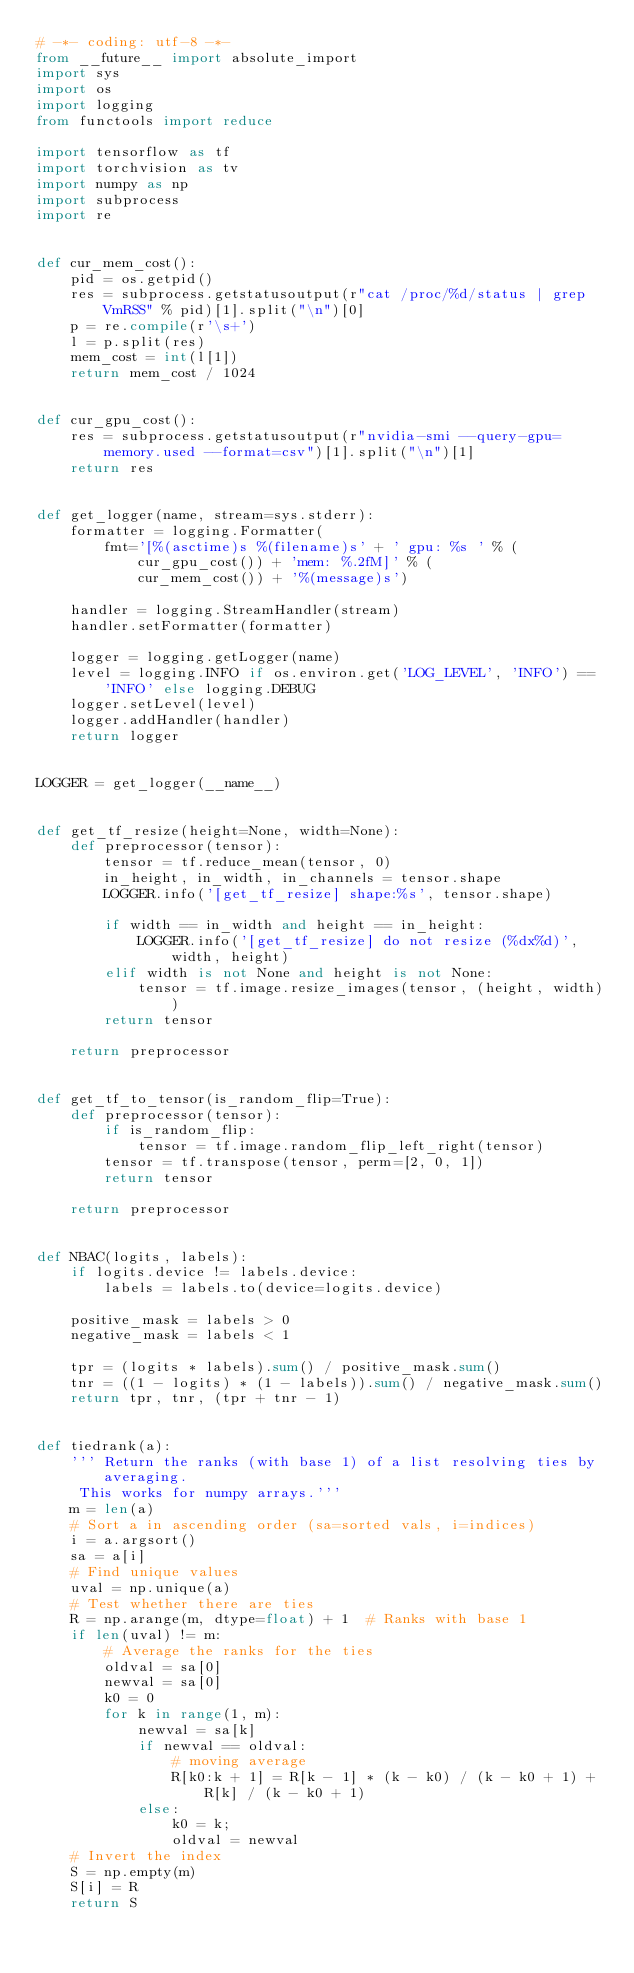<code> <loc_0><loc_0><loc_500><loc_500><_Python_># -*- coding: utf-8 -*-
from __future__ import absolute_import
import sys
import os
import logging
from functools import reduce

import tensorflow as tf
import torchvision as tv
import numpy as np
import subprocess
import re


def cur_mem_cost():
    pid = os.getpid()
    res = subprocess.getstatusoutput(r"cat /proc/%d/status | grep VmRSS" % pid)[1].split("\n")[0]
    p = re.compile(r'\s+')
    l = p.split(res)
    mem_cost = int(l[1])
    return mem_cost / 1024


def cur_gpu_cost():
    res = subprocess.getstatusoutput(r"nvidia-smi --query-gpu=memory.used --format=csv")[1].split("\n")[1]
    return res


def get_logger(name, stream=sys.stderr):
    formatter = logging.Formatter(
        fmt='[%(asctime)s %(filename)s' + ' gpu: %s ' % (cur_gpu_cost()) + 'mem: %.2fM]' % (
            cur_mem_cost()) + '%(message)s')

    handler = logging.StreamHandler(stream)
    handler.setFormatter(formatter)

    logger = logging.getLogger(name)
    level = logging.INFO if os.environ.get('LOG_LEVEL', 'INFO') == 'INFO' else logging.DEBUG
    logger.setLevel(level)
    logger.addHandler(handler)
    return logger


LOGGER = get_logger(__name__)


def get_tf_resize(height=None, width=None):
    def preprocessor(tensor):
        tensor = tf.reduce_mean(tensor, 0)
        in_height, in_width, in_channels = tensor.shape
        LOGGER.info('[get_tf_resize] shape:%s', tensor.shape)

        if width == in_width and height == in_height:
            LOGGER.info('[get_tf_resize] do not resize (%dx%d)', width, height)
        elif width is not None and height is not None:
            tensor = tf.image.resize_images(tensor, (height, width))
        return tensor

    return preprocessor


def get_tf_to_tensor(is_random_flip=True):
    def preprocessor(tensor):
        if is_random_flip:
            tensor = tf.image.random_flip_left_right(tensor)
        tensor = tf.transpose(tensor, perm=[2, 0, 1])
        return tensor

    return preprocessor


def NBAC(logits, labels):
    if logits.device != labels.device:
        labels = labels.to(device=logits.device)

    positive_mask = labels > 0
    negative_mask = labels < 1

    tpr = (logits * labels).sum() / positive_mask.sum()
    tnr = ((1 - logits) * (1 - labels)).sum() / negative_mask.sum()
    return tpr, tnr, (tpr + tnr - 1)


def tiedrank(a):
    ''' Return the ranks (with base 1) of a list resolving ties by averaging.
     This works for numpy arrays.'''
    m = len(a)
    # Sort a in ascending order (sa=sorted vals, i=indices)
    i = a.argsort()
    sa = a[i]
    # Find unique values
    uval = np.unique(a)
    # Test whether there are ties
    R = np.arange(m, dtype=float) + 1  # Ranks with base 1
    if len(uval) != m:
        # Average the ranks for the ties
        oldval = sa[0]
        newval = sa[0]
        k0 = 0
        for k in range(1, m):
            newval = sa[k]
            if newval == oldval:
                # moving average
                R[k0:k + 1] = R[k - 1] * (k - k0) / (k - k0 + 1) + R[k] / (k - k0 + 1)
            else:
                k0 = k;
                oldval = newval
    # Invert the index
    S = np.empty(m)
    S[i] = R
    return S

</code> 